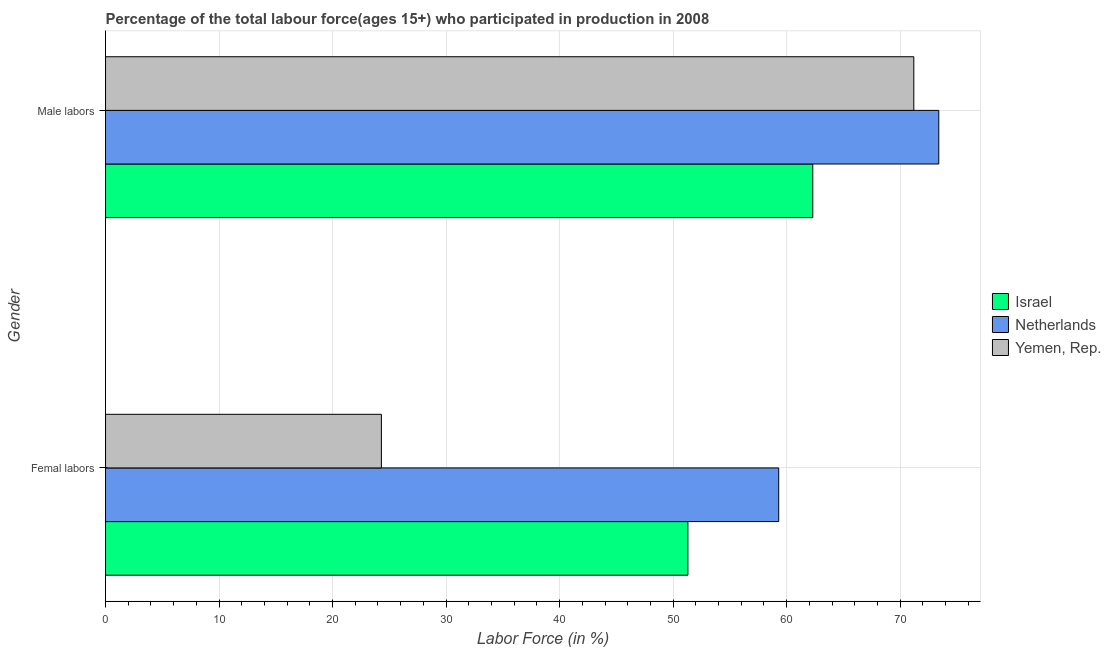How many different coloured bars are there?
Ensure brevity in your answer.  3. How many groups of bars are there?
Keep it short and to the point. 2. Are the number of bars on each tick of the Y-axis equal?
Your response must be concise. Yes. How many bars are there on the 2nd tick from the bottom?
Make the answer very short. 3. What is the label of the 1st group of bars from the top?
Your answer should be compact. Male labors. What is the percentage of male labour force in Netherlands?
Keep it short and to the point. 73.4. Across all countries, what is the maximum percentage of male labour force?
Your answer should be very brief. 73.4. Across all countries, what is the minimum percentage of male labour force?
Your answer should be compact. 62.3. What is the total percentage of female labor force in the graph?
Provide a succinct answer. 134.9. What is the difference between the percentage of male labour force in Netherlands and that in Israel?
Make the answer very short. 11.1. What is the difference between the percentage of male labour force in Netherlands and the percentage of female labor force in Israel?
Provide a short and direct response. 22.1. What is the average percentage of female labor force per country?
Give a very brief answer. 44.97. What is the ratio of the percentage of female labor force in Yemen, Rep. to that in Netherlands?
Keep it short and to the point. 0.41. Is the percentage of female labor force in Netherlands less than that in Israel?
Provide a succinct answer. No. In how many countries, is the percentage of female labor force greater than the average percentage of female labor force taken over all countries?
Your answer should be compact. 2. What does the 1st bar from the top in Male labors represents?
Offer a very short reply. Yemen, Rep. How many bars are there?
Your answer should be compact. 6. What is the difference between two consecutive major ticks on the X-axis?
Provide a succinct answer. 10. Are the values on the major ticks of X-axis written in scientific E-notation?
Your response must be concise. No. How many legend labels are there?
Your answer should be compact. 3. How are the legend labels stacked?
Your answer should be very brief. Vertical. What is the title of the graph?
Make the answer very short. Percentage of the total labour force(ages 15+) who participated in production in 2008. Does "Northern Mariana Islands" appear as one of the legend labels in the graph?
Ensure brevity in your answer.  No. What is the Labor Force (in %) in Israel in Femal labors?
Provide a succinct answer. 51.3. What is the Labor Force (in %) in Netherlands in Femal labors?
Offer a very short reply. 59.3. What is the Labor Force (in %) in Yemen, Rep. in Femal labors?
Your response must be concise. 24.3. What is the Labor Force (in %) in Israel in Male labors?
Make the answer very short. 62.3. What is the Labor Force (in %) in Netherlands in Male labors?
Offer a very short reply. 73.4. What is the Labor Force (in %) of Yemen, Rep. in Male labors?
Provide a succinct answer. 71.2. Across all Gender, what is the maximum Labor Force (in %) in Israel?
Your response must be concise. 62.3. Across all Gender, what is the maximum Labor Force (in %) of Netherlands?
Your answer should be compact. 73.4. Across all Gender, what is the maximum Labor Force (in %) of Yemen, Rep.?
Your answer should be compact. 71.2. Across all Gender, what is the minimum Labor Force (in %) of Israel?
Give a very brief answer. 51.3. Across all Gender, what is the minimum Labor Force (in %) of Netherlands?
Make the answer very short. 59.3. Across all Gender, what is the minimum Labor Force (in %) in Yemen, Rep.?
Make the answer very short. 24.3. What is the total Labor Force (in %) in Israel in the graph?
Provide a succinct answer. 113.6. What is the total Labor Force (in %) of Netherlands in the graph?
Your answer should be compact. 132.7. What is the total Labor Force (in %) of Yemen, Rep. in the graph?
Ensure brevity in your answer.  95.5. What is the difference between the Labor Force (in %) in Israel in Femal labors and that in Male labors?
Ensure brevity in your answer.  -11. What is the difference between the Labor Force (in %) in Netherlands in Femal labors and that in Male labors?
Your answer should be very brief. -14.1. What is the difference between the Labor Force (in %) in Yemen, Rep. in Femal labors and that in Male labors?
Provide a succinct answer. -46.9. What is the difference between the Labor Force (in %) in Israel in Femal labors and the Labor Force (in %) in Netherlands in Male labors?
Give a very brief answer. -22.1. What is the difference between the Labor Force (in %) of Israel in Femal labors and the Labor Force (in %) of Yemen, Rep. in Male labors?
Offer a very short reply. -19.9. What is the average Labor Force (in %) in Israel per Gender?
Your answer should be very brief. 56.8. What is the average Labor Force (in %) of Netherlands per Gender?
Your response must be concise. 66.35. What is the average Labor Force (in %) in Yemen, Rep. per Gender?
Provide a short and direct response. 47.75. What is the difference between the Labor Force (in %) of Israel and Labor Force (in %) of Netherlands in Femal labors?
Your answer should be compact. -8. What is the difference between the Labor Force (in %) of Netherlands and Labor Force (in %) of Yemen, Rep. in Femal labors?
Your response must be concise. 35. What is the difference between the Labor Force (in %) of Israel and Labor Force (in %) of Netherlands in Male labors?
Provide a succinct answer. -11.1. What is the difference between the Labor Force (in %) in Israel and Labor Force (in %) in Yemen, Rep. in Male labors?
Provide a short and direct response. -8.9. What is the ratio of the Labor Force (in %) in Israel in Femal labors to that in Male labors?
Make the answer very short. 0.82. What is the ratio of the Labor Force (in %) of Netherlands in Femal labors to that in Male labors?
Ensure brevity in your answer.  0.81. What is the ratio of the Labor Force (in %) in Yemen, Rep. in Femal labors to that in Male labors?
Provide a succinct answer. 0.34. What is the difference between the highest and the second highest Labor Force (in %) of Israel?
Your answer should be compact. 11. What is the difference between the highest and the second highest Labor Force (in %) in Yemen, Rep.?
Provide a short and direct response. 46.9. What is the difference between the highest and the lowest Labor Force (in %) of Israel?
Provide a succinct answer. 11. What is the difference between the highest and the lowest Labor Force (in %) in Yemen, Rep.?
Give a very brief answer. 46.9. 